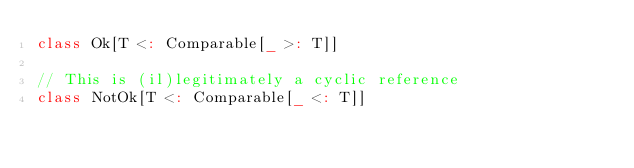<code> <loc_0><loc_0><loc_500><loc_500><_Scala_>class Ok[T <: Comparable[_ >: T]]

// This is (il)legitimately a cyclic reference
class NotOk[T <: Comparable[_ <: T]]
</code> 